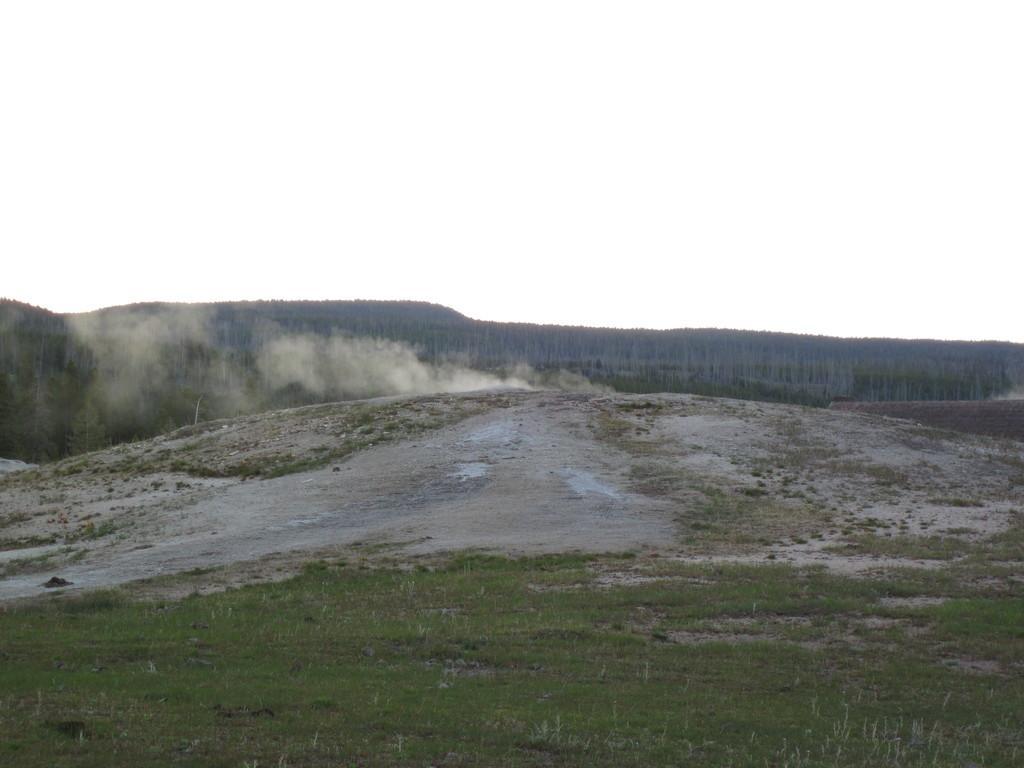In one or two sentences, can you explain what this image depicts? In this image there is a hill view and smoke visible in the middle, at the top there is the sky. 